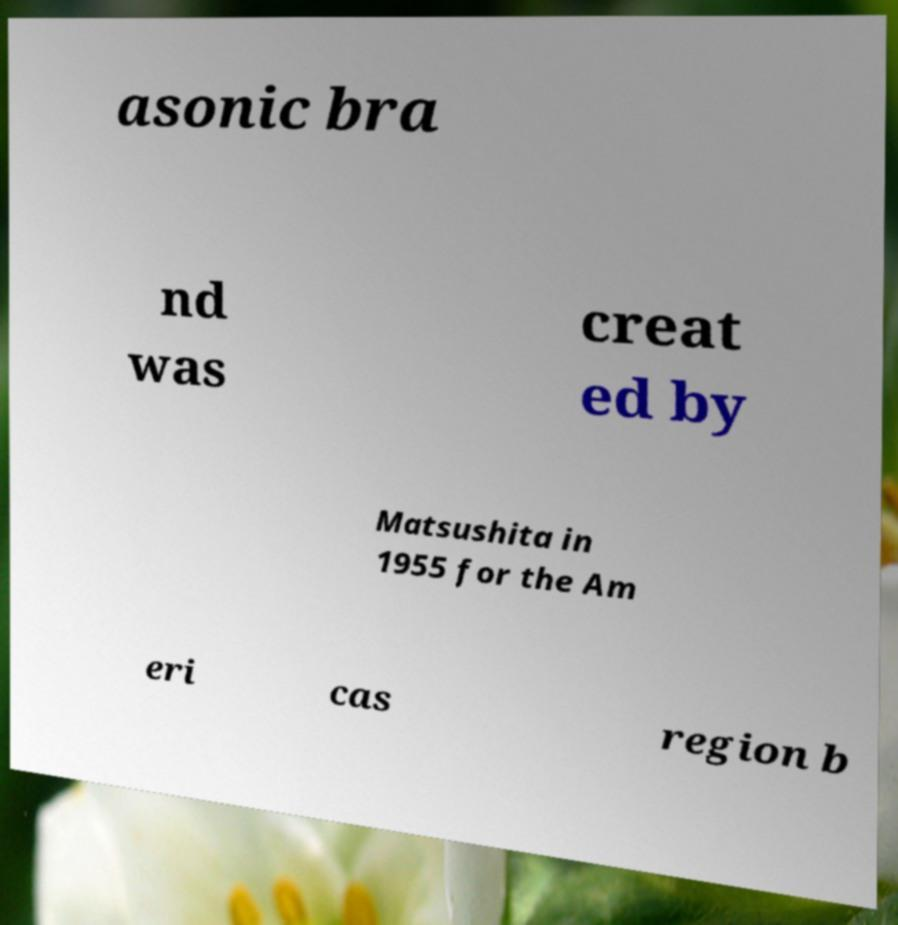Could you extract and type out the text from this image? asonic bra nd was creat ed by Matsushita in 1955 for the Am eri cas region b 